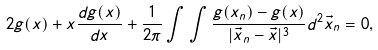Convert formula to latex. <formula><loc_0><loc_0><loc_500><loc_500>2 g ( x ) + x \frac { d g ( x ) } { d x } + \frac { 1 } { 2 \pi } \int \int \frac { g ( x _ { n } ) - g ( x ) } { | \vec { x } _ { n } - \vec { x } | ^ { 3 } } d ^ { 2 } \vec { x } _ { n } = 0 ,</formula> 